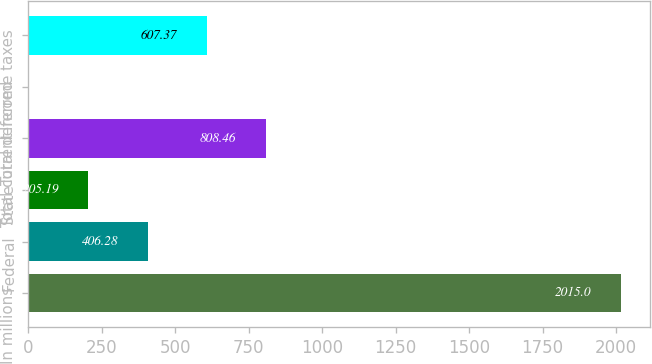Convert chart to OTSL. <chart><loc_0><loc_0><loc_500><loc_500><bar_chart><fcel>In millions<fcel>Federal<fcel>State<fcel>Total current<fcel>Total deferred<fcel>Income taxes<nl><fcel>2015<fcel>406.28<fcel>205.19<fcel>808.46<fcel>4.1<fcel>607.37<nl></chart> 